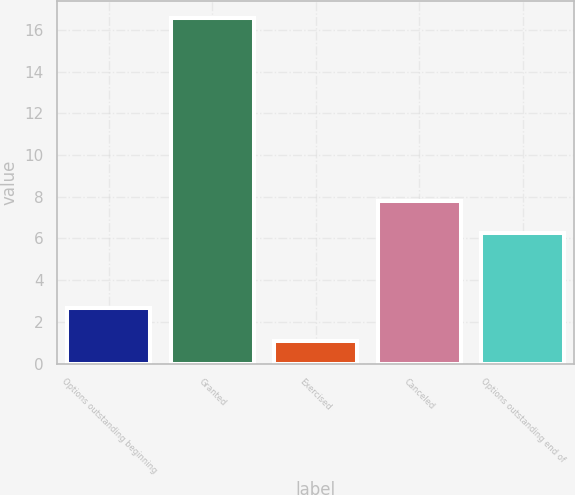Convert chart to OTSL. <chart><loc_0><loc_0><loc_500><loc_500><bar_chart><fcel>Options outstanding beginning<fcel>Granted<fcel>Exercised<fcel>Canceled<fcel>Options outstanding end of<nl><fcel>2.65<fcel>16.55<fcel>1.1<fcel>7.79<fcel>6.25<nl></chart> 